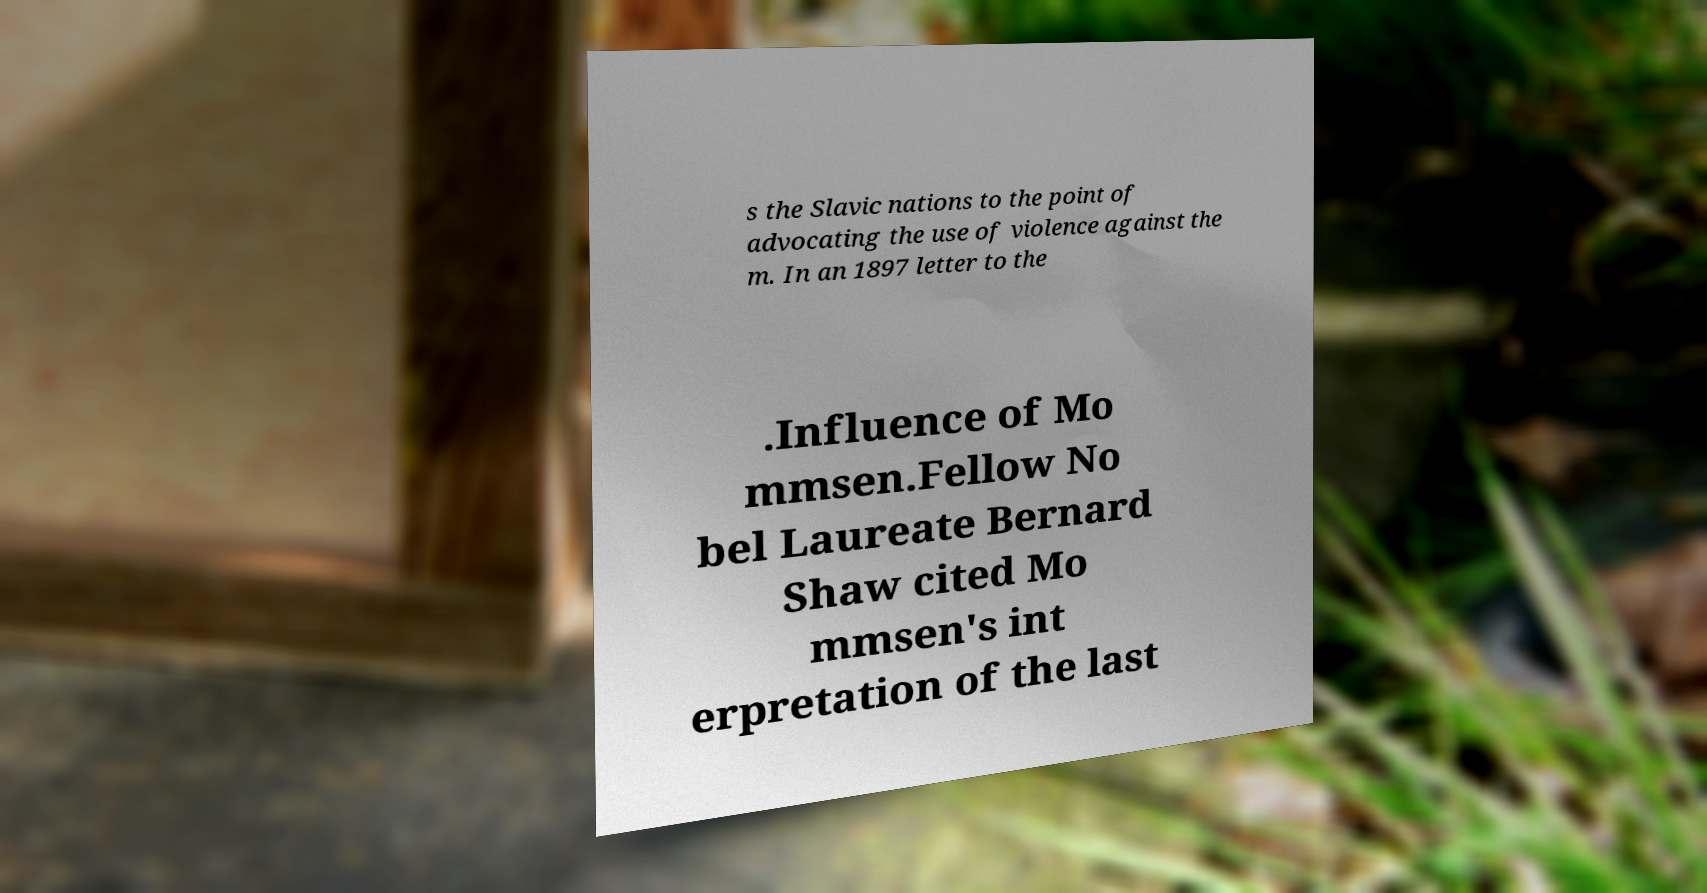There's text embedded in this image that I need extracted. Can you transcribe it verbatim? s the Slavic nations to the point of advocating the use of violence against the m. In an 1897 letter to the .Influence of Mo mmsen.Fellow No bel Laureate Bernard Shaw cited Mo mmsen's int erpretation of the last 